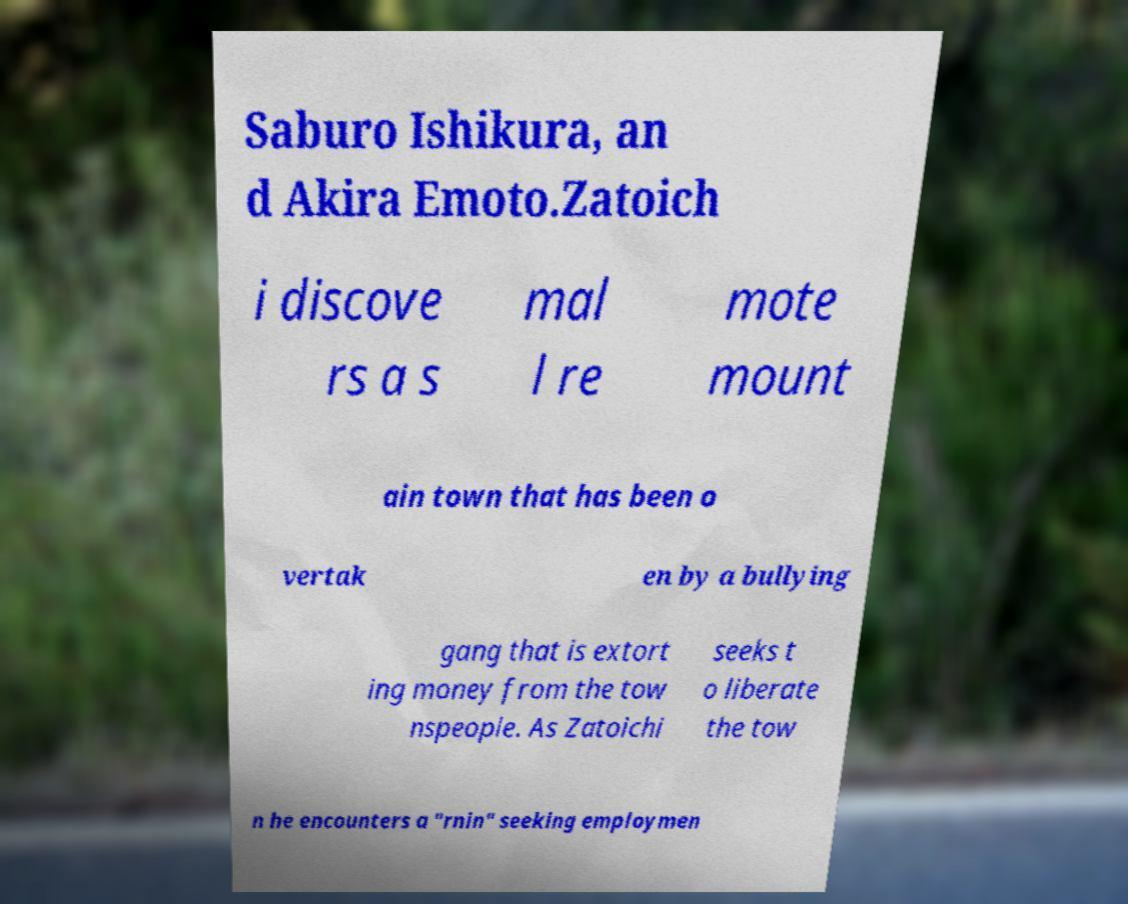For documentation purposes, I need the text within this image transcribed. Could you provide that? Saburo Ishikura, an d Akira Emoto.Zatoich i discove rs a s mal l re mote mount ain town that has been o vertak en by a bullying gang that is extort ing money from the tow nspeople. As Zatoichi seeks t o liberate the tow n he encounters a "rnin" seeking employmen 